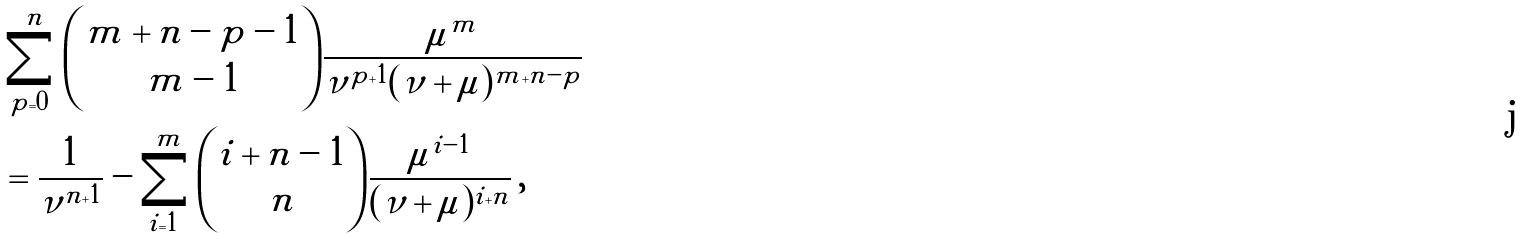Convert formula to latex. <formula><loc_0><loc_0><loc_500><loc_500>& \sum _ { p = 0 } ^ { n } { \binom { m + n - p - 1 } { m - 1 } \frac { \mu ^ { m } } { { \nu ^ { p + 1 } ( \nu + \mu ) ^ { m + n - p } } } } \\ & = \frac { 1 } { { \nu ^ { n + 1 } } } - \sum _ { i = 1 } ^ { m } { \binom { i + n - 1 } n \frac { { \mu ^ { i - 1 } } } { { ( \nu + \mu ) ^ { i + n } } } } \, ,</formula> 